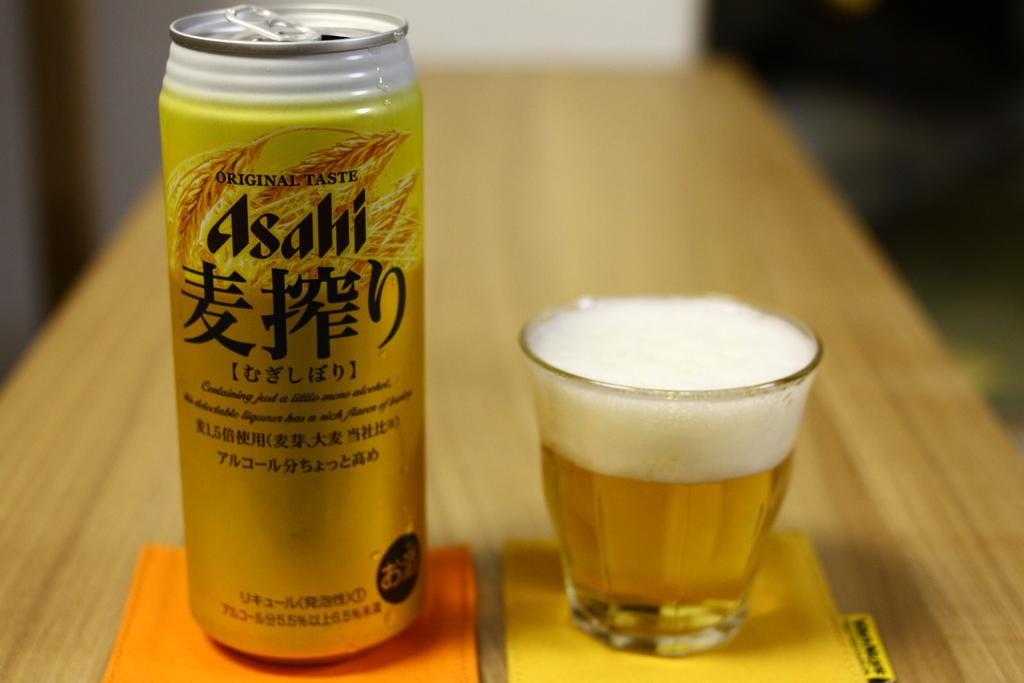<image>
Create a compact narrative representing the image presented. the word Asahi is on the can which is gold 